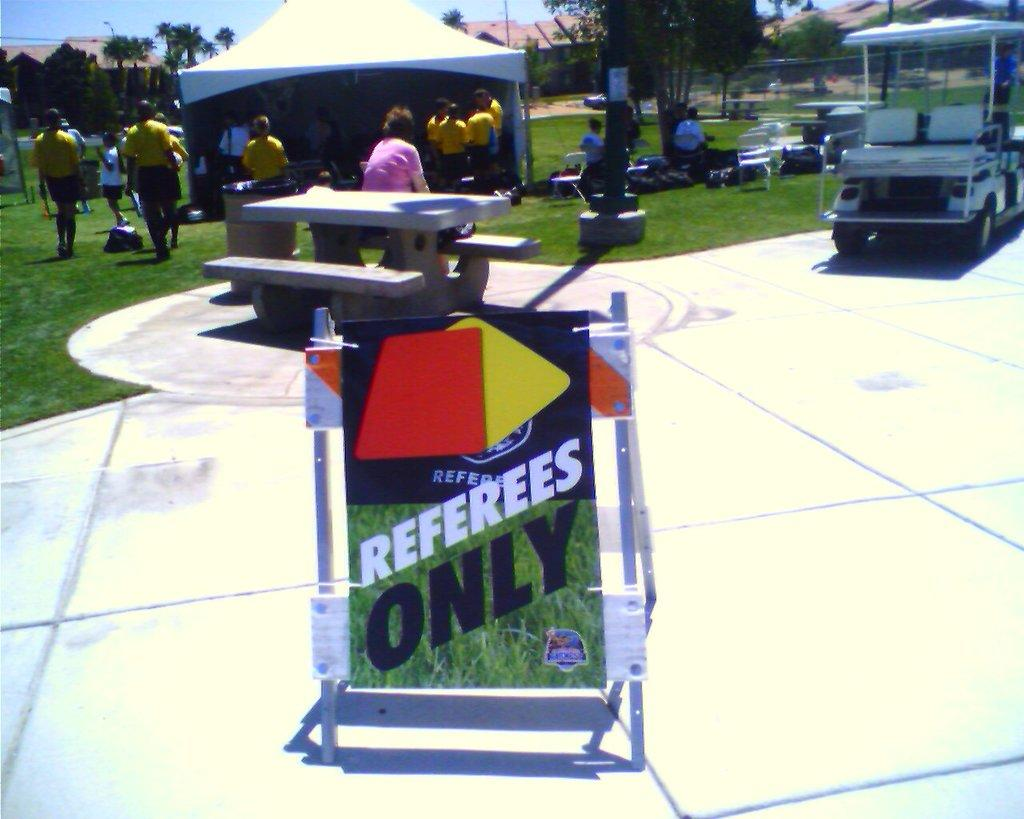Provide a one-sentence caption for the provided image. Several people are gathered on a green, grass field, with a sigh in front that permits referees only. 